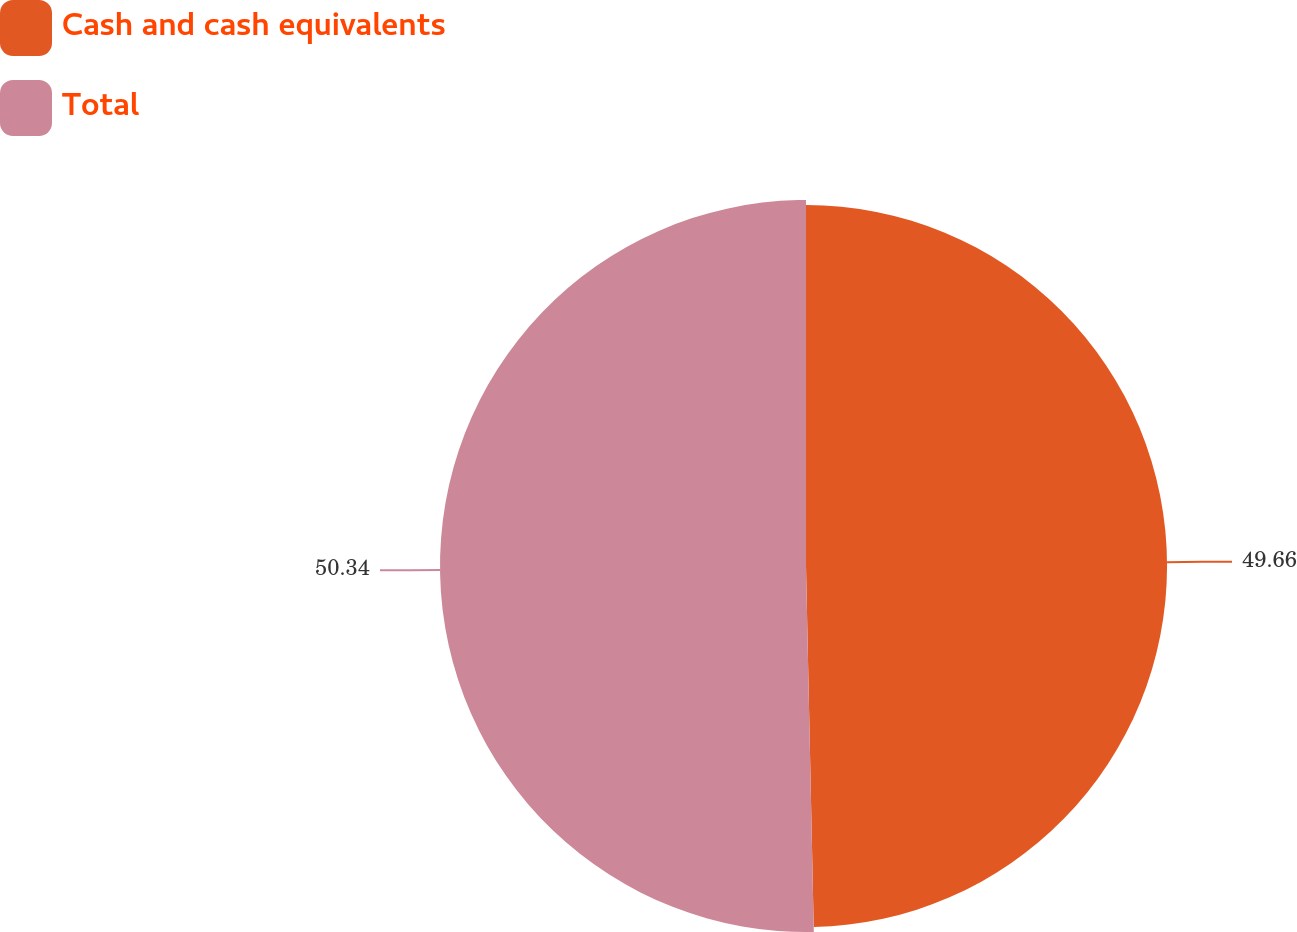<chart> <loc_0><loc_0><loc_500><loc_500><pie_chart><fcel>Cash and cash equivalents<fcel>Total<nl><fcel>49.66%<fcel>50.34%<nl></chart> 